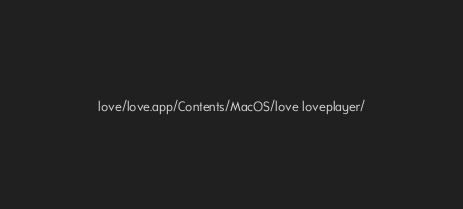<code> <loc_0><loc_0><loc_500><loc_500><_Bash_>love/love.app/Contents/MacOS/love loveplayer/</code> 